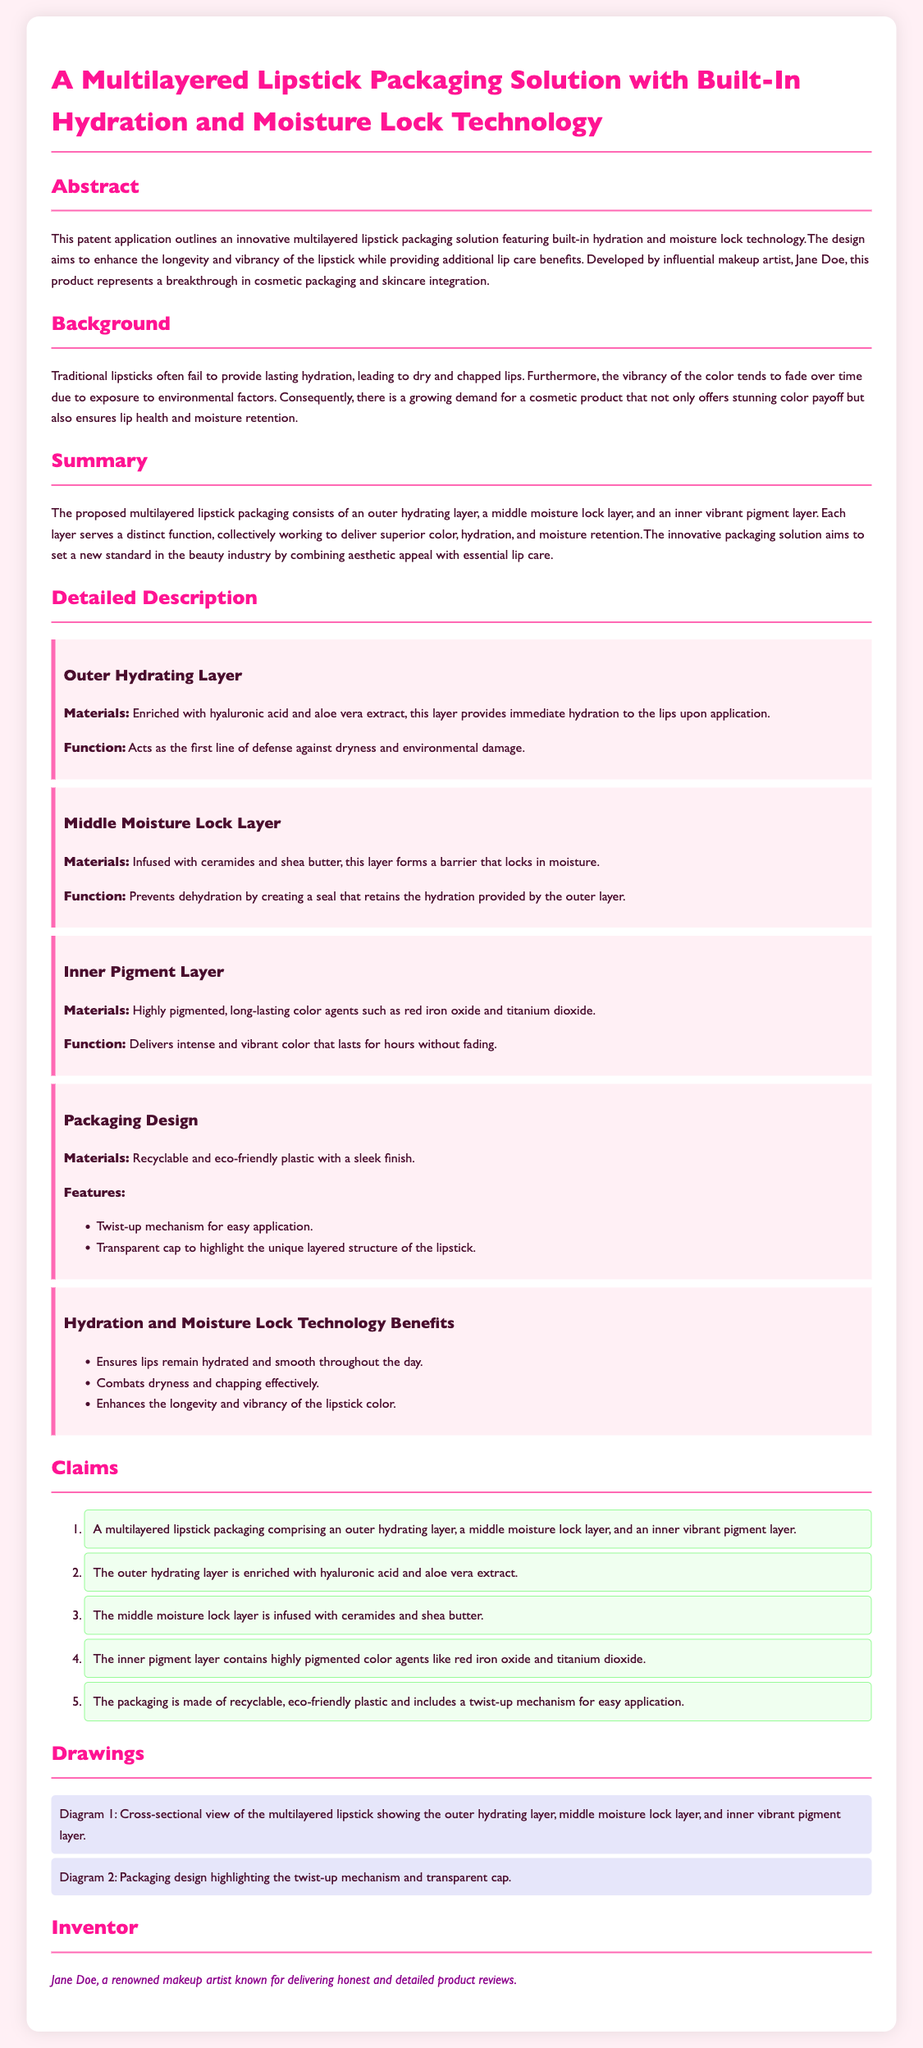What is the main feature of the lipstick packaging? The primary feature outlined in the document is the multilayered design with built-in hydration and moisture lock technology.
Answer: multilayered design with built-in hydration and moisture lock technology Who is the inventor of the lipstick packaging? The document states that the inventor is Jane Doe, a renowned makeup artist.
Answer: Jane Doe What material is the outer hydrating layer enriched with? It is specified in the document that the outer hydrating layer is enriched with hyaluronic acid and aloe vera extract.
Answer: hyaluronic acid and aloe vera extract What is the purpose of the middle moisture lock layer? The function of this layer is to prevent dehydration by creating a seal that retains the hydration provided by the outer layer.
Answer: Prevents dehydration by creating a seal How many claims are made in the patent application? The claims section lists five specific claims made regarding the multilayered lipstick.
Answer: five What does the inner pigment layer contain? The inner pigment layer is stated to contain highly pigmented color agents such as red iron oxide and titanium dioxide.
Answer: red iron oxide and titanium dioxide What kind of packaging material is used? The document mentions that the packaging is made of recyclable and eco-friendly plastic.
Answer: recyclable and eco-friendly plastic What benefits does the hydration and moisture lock technology provide? The technology ensures lips remain hydrated and smooth throughout the day, combats dryness, and enhances longevity and vibrancy of lipstick color.
Answer: Ensures lips remain hydrated and smooth, combats dryness, enhances longevity and vibrancy 